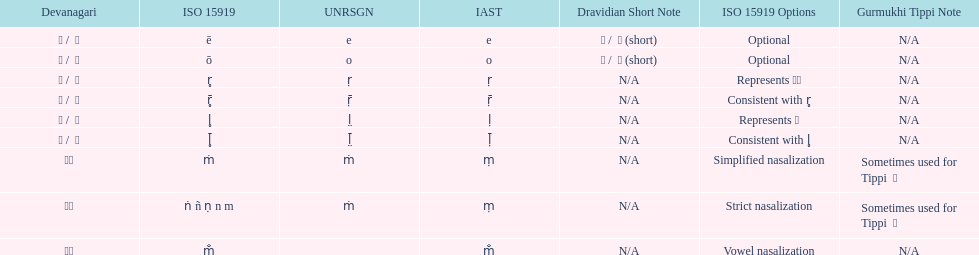What iast is listed before the o? E. 